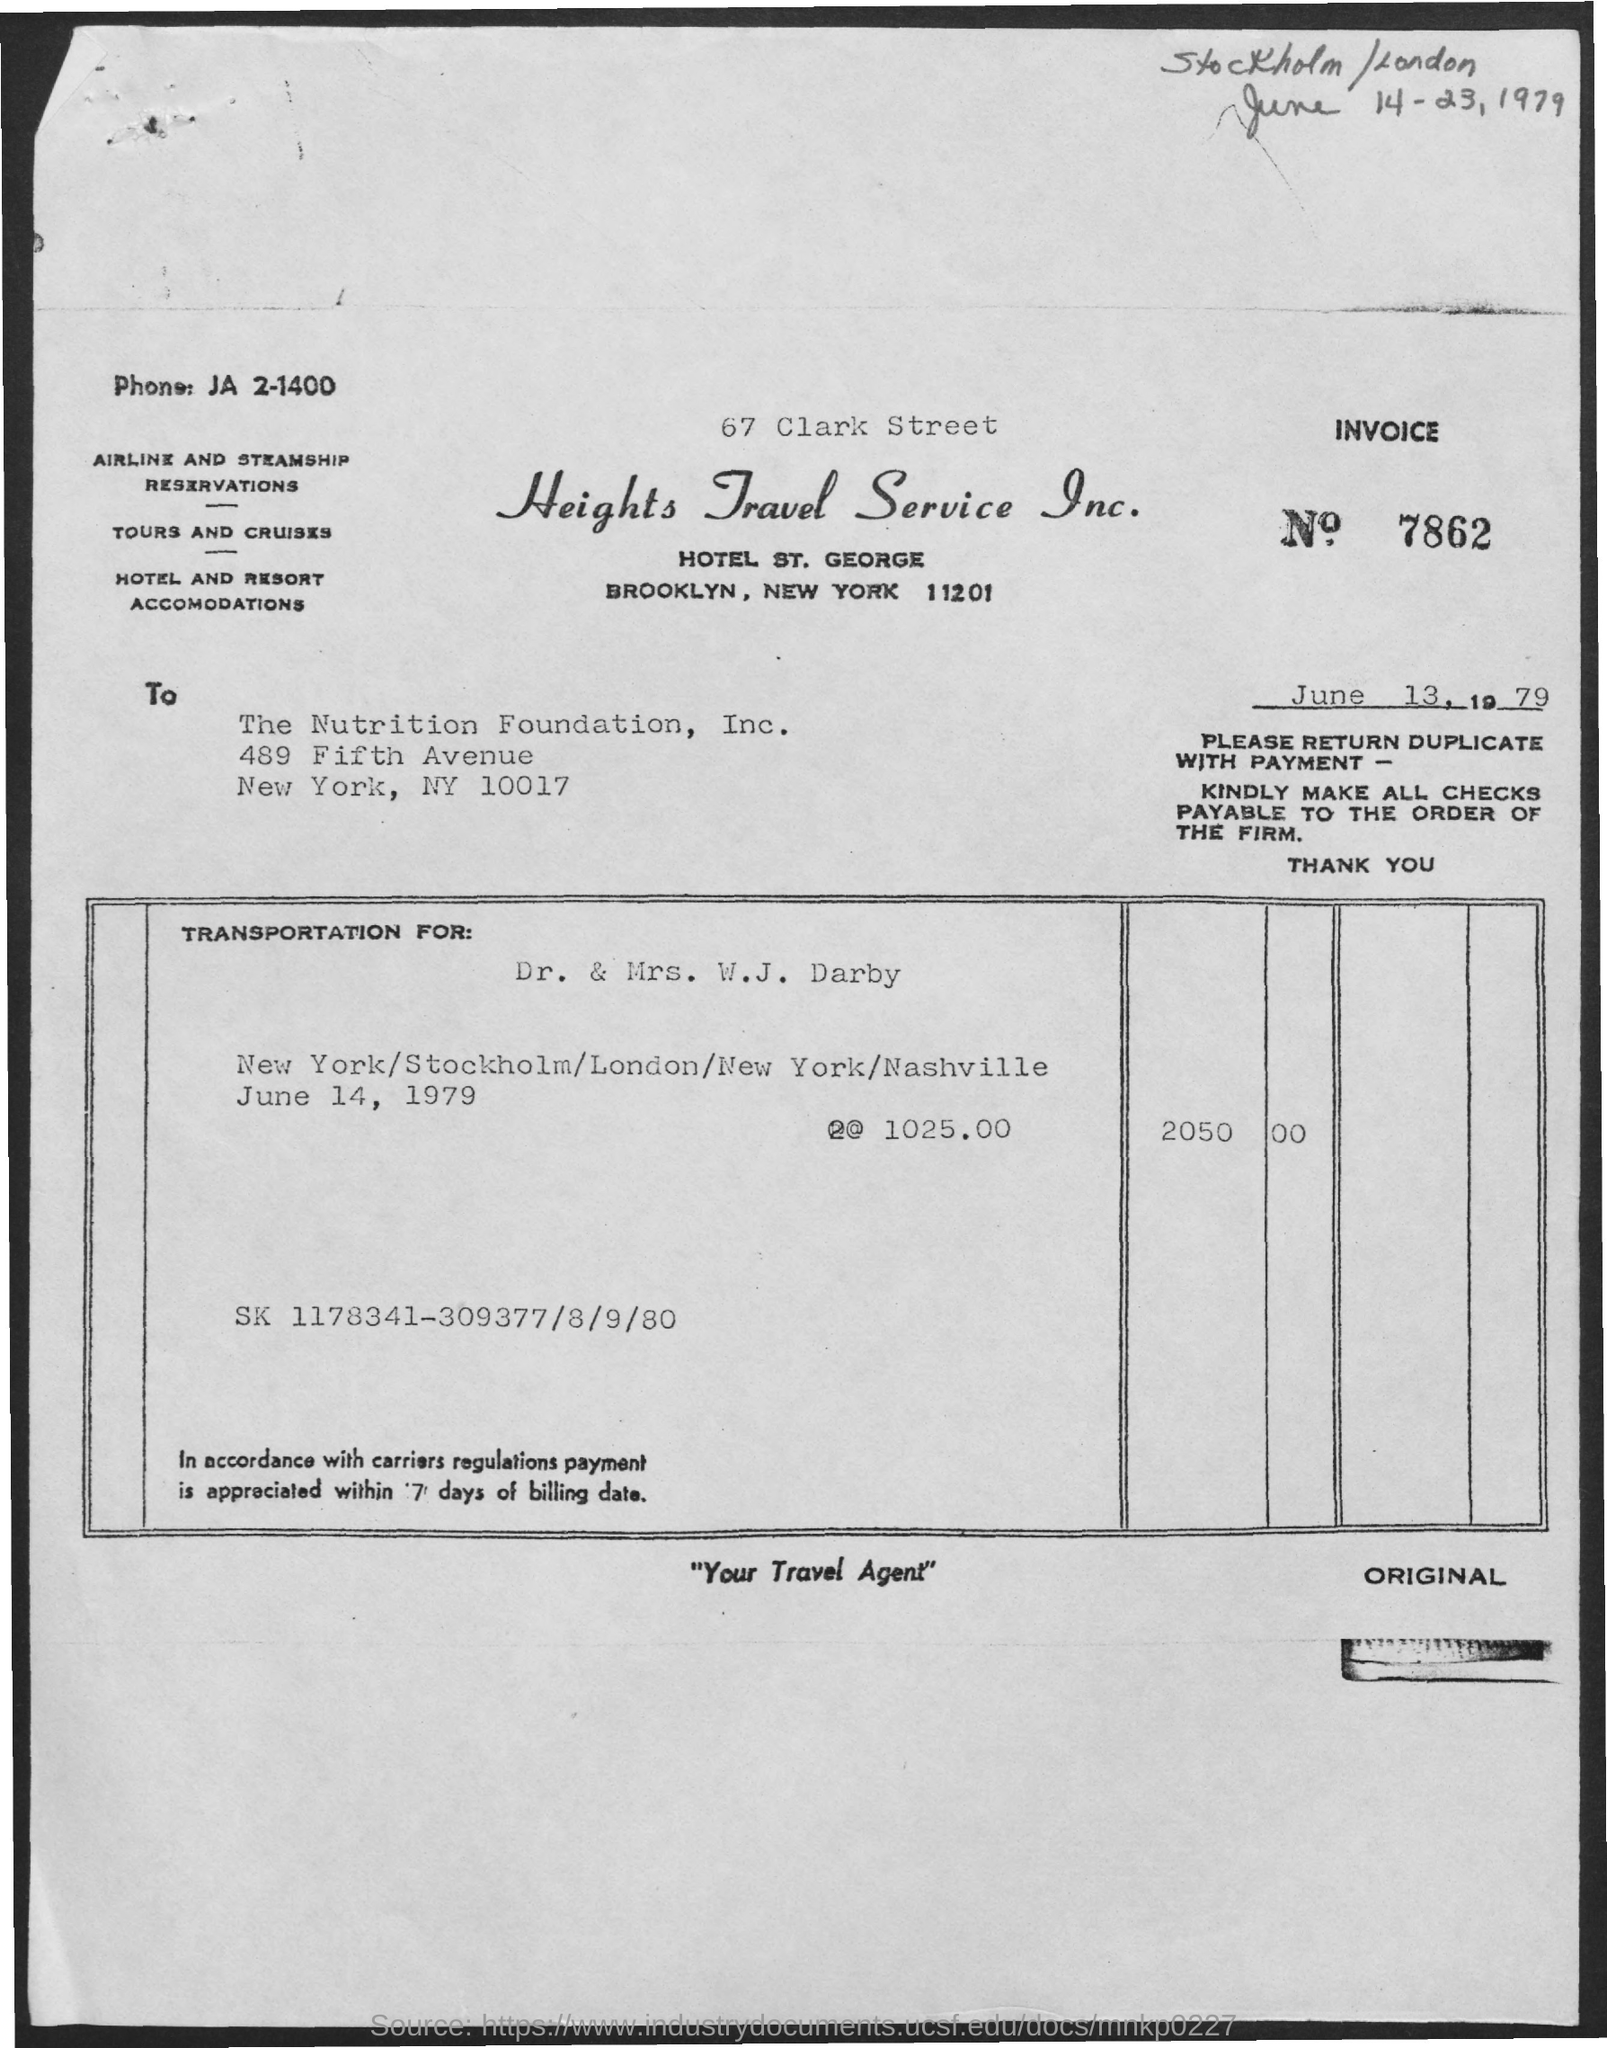What is the Invoice No.?
Offer a very short reply. 7862. Who is the transportation for?
Make the answer very short. Dr. & mrs. w.j. darby. What is the Total amount?
Provide a succinct answer. 2050.00. 